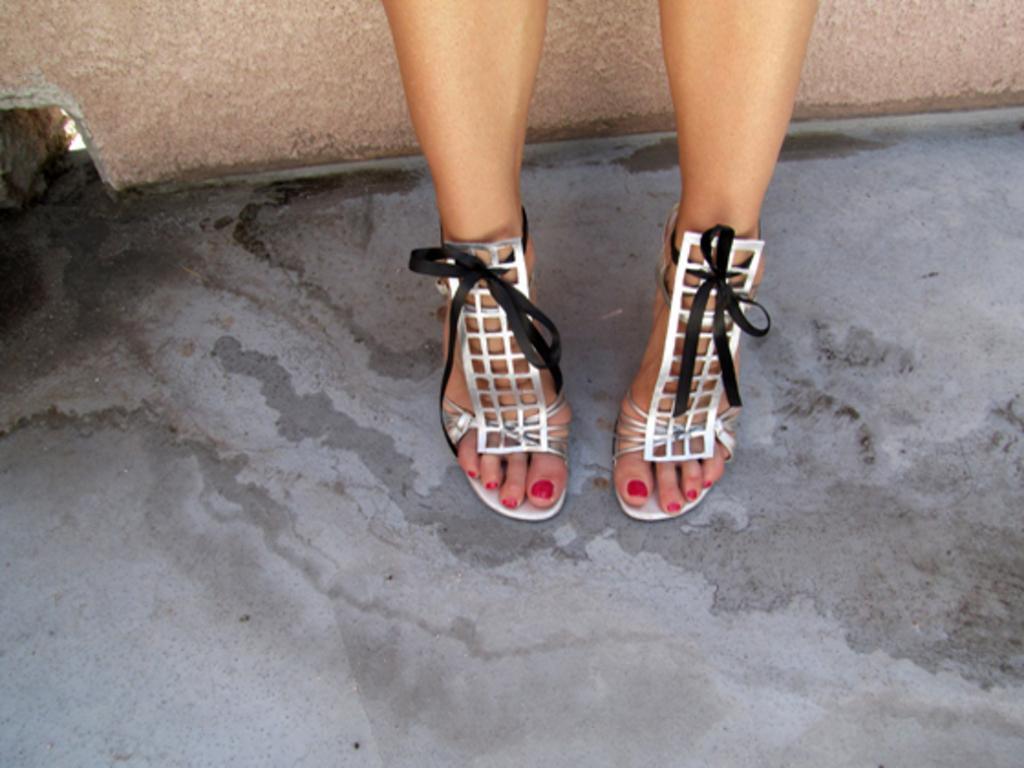Can you describe this image briefly? In this image, we can see the legs of a person with footwear on the surface. At the top of the image, there is a wall. 